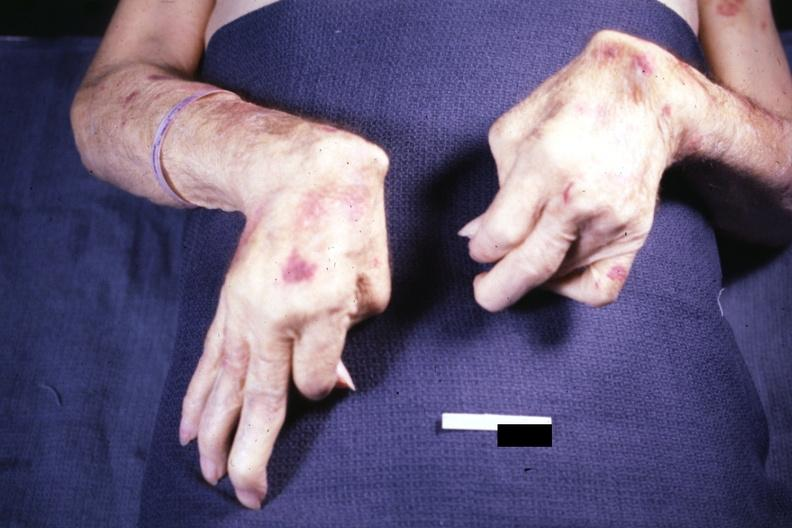what is present?
Answer the question using a single word or phrase. Hand 